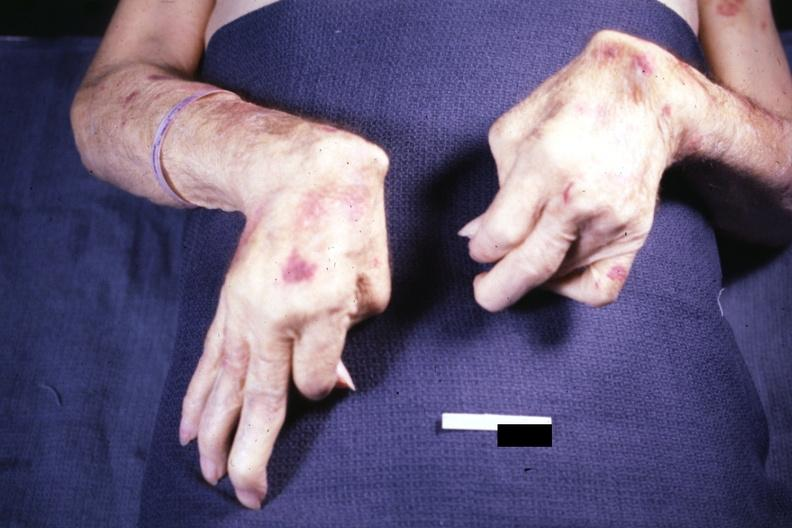what is present?
Answer the question using a single word or phrase. Hand 